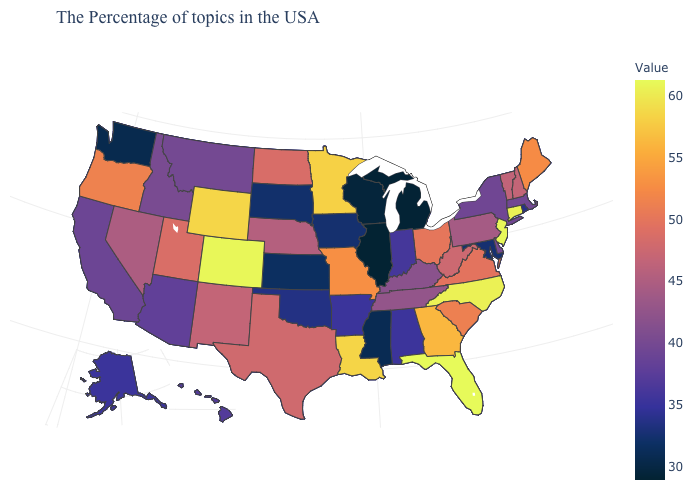Among the states that border Connecticut , which have the highest value?
Answer briefly. Massachusetts. Among the states that border Texas , which have the lowest value?
Quick response, please. Oklahoma. Does Iowa have a lower value than Illinois?
Quick response, please. No. Which states have the lowest value in the MidWest?
Write a very short answer. Illinois. Does Hawaii have the highest value in the USA?
Be succinct. No. Among the states that border Maryland , does Virginia have the highest value?
Short answer required. Yes. 